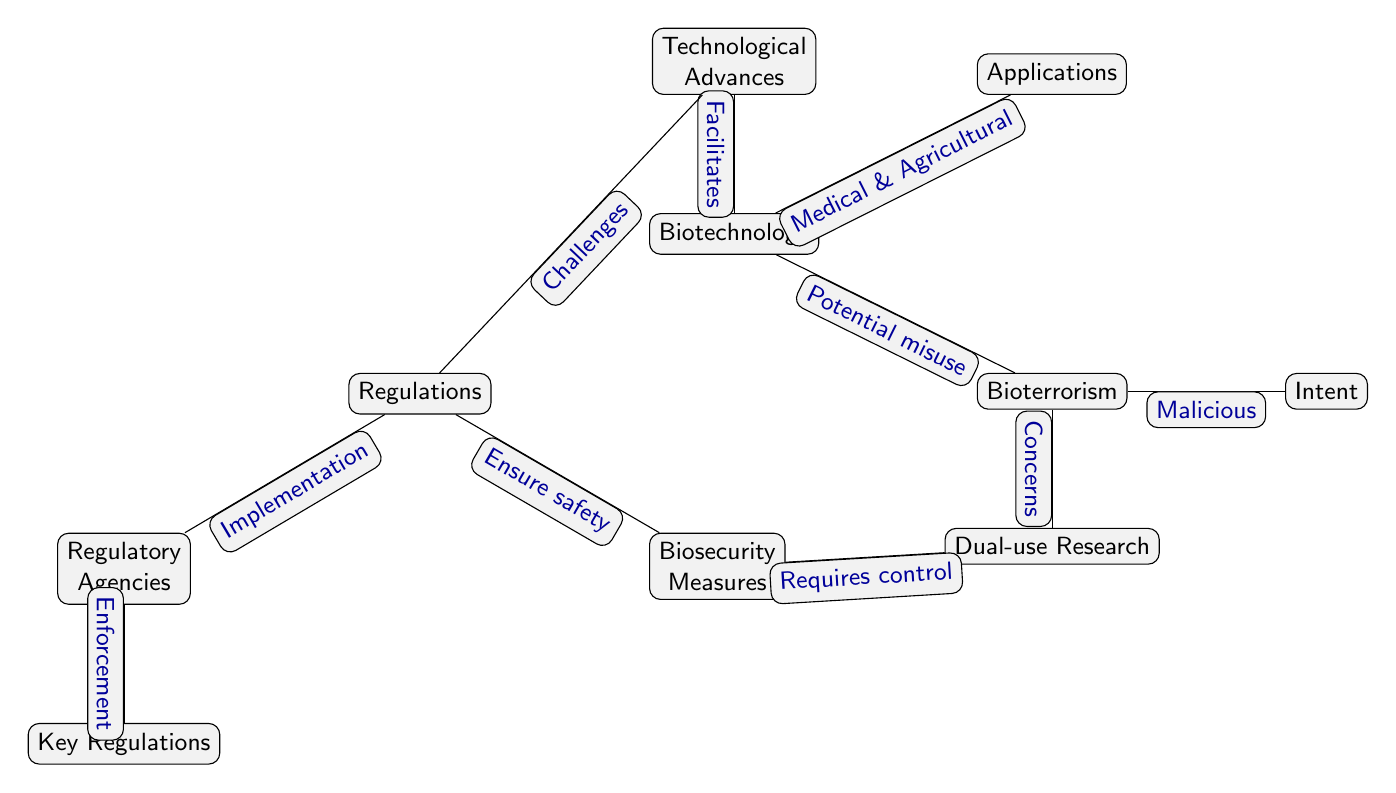What are the two main focuses of biotechnology as shown in the diagram? The diagram lists "Medical & Agricultural" as the applications of biotechnology, which reflects its major areas of focus. Thus, the two main focuses are "Medical" and "Agricultural".
Answer: Medical & Agricultural Which node has a direct relationship with both bioterrorism and regulations? The node "Biotechnology" is directly connected to both "Bioterrorism" (indicating its potential misuse) and "Regulations" (as part of ensuring safety), highlighting its central role in the diagram.
Answer: Biotechnology How many regulatory agencies are mentioned? The diagram includes one node labeled "Regulatory Agencies", indicating there is a singular reference to those responsible for regulation in the context of biotechnology and bioterrorism.
Answer: One What is the required control for dual-use research according to the diagram? The diagram states "Requires control" as the action needed for "Dual-use Research", which addresses the concerns associated with research that can be misused.
Answer: Requires control What does technology facilitate in the context of bioterrorism? The diagram links "Technological Advances" that facilitate "Biotechnology", indicating that technological developments contribute to advancements in the biotechnology field, which includes potential threats like bioterrorism.
Answer: Biotechnology Which edge represents the concern stemming from bioterrorism? The diagram shows an edge labeled "Concerns" that connects "Bioterrorism" and "Dual-use Research", illustrating the worries that arise from the potential misuse of research in a bioterrorism context.
Answer: Concerns What measures are associated with the regulation of biotechnology? The diagram indicates that "Biosecurity Measures" are established as a response under "Regulations" to ensure safety concerning biotechnology applications, particularly in mitigating bioterrorism threats.
Answer: Biosecurity Measures What action do regulatory agencies perform according to the diagram? The diagram indicates that regulatory agencies are responsible for "Implementation", which means they put regulations into practice concerning biotechnology and bioterrorism.
Answer: Implementation What is the relationship between biotechnology and technological advances? The diagram shows that "Technological Advances" facilitate "Biotechnology", meaning innovations in technology are crucial to enhancing and advancing biotechnological practices.
Answer: Facilitate What is the intention behind bioterrorism depicted in this diagram? The diagram explicitly states "Malicious" as the intent behind bioterrorism, indicating that the use of biological agents for harm is driven by malicious purposes.
Answer: Malicious 